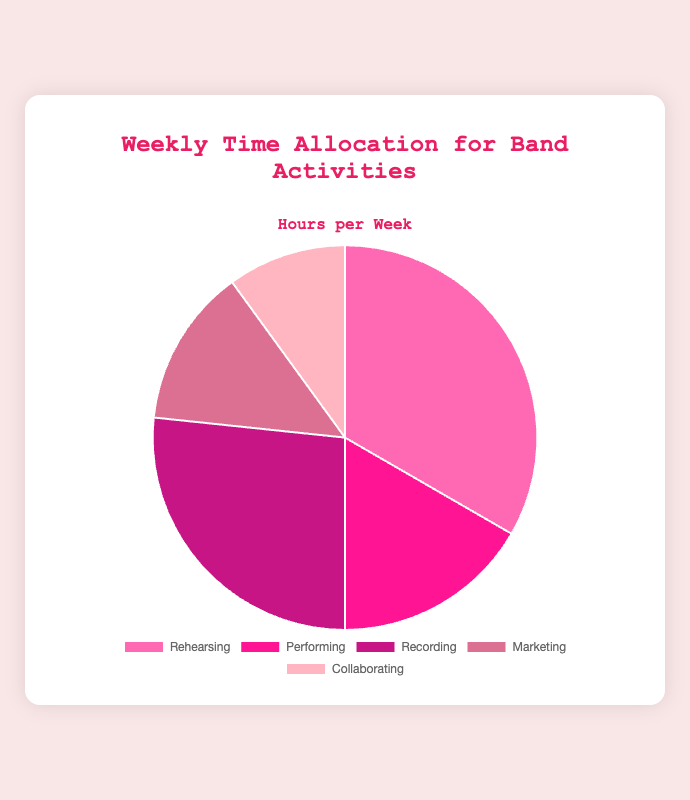What's the total amount of time allocated to Rehearsing and Recording? To find the total time, add the hours for Rehearsing (10) and Recording (8) together: 10 + 8 = 18 hours
Answer: 18 hours Which activity takes up the least amount of time? Collaborating has the smallest value (3 hours) compared to the other activities: Rehearsing (10), Performing (5), Recording (8), and Marketing (4)
Answer: Collaborating How much more time is spent Rehearsing than Marketing? To find the difference in time, subtract the hours for Marketing (4) from Rehearsing (10): 10 - 4 = 6 hours
Answer: 6 hours What's the combined time spent on Performing and Collaborating? Add the hours for Performing (5) and Collaborating (3) together: 5 + 3 = 8 hours
Answer: 8 hours Which activity has approximately one-fifth of the total time allocated? The total time is 30 hours. One-fifth of 30 is 6. Comparing this to individual activities, Performing (5) is closest to 6 hours
Answer: Performing What is the largest segment in the pie chart, and what color represents it? Rehearsing has the largest value (10 hours). The color representing Rehearsing is pink.
Answer: Rehearsing, pink How much more time is spent on Recording than Collaborating? Subtract the hours for Collaborating (3) from Recording (8): 8 - 3 = 5 hours
Answer: 5 hours Which activity takes a quarter of the total weekly time? The total time is 30 hours. A quarter of 30 is 7.5. Recording (8 hours) is closest to 7.5 hours.
Answer: Recording Is the time spent on Marketing more or less than the total time spent on Performing and Collaborating together? The total time for Performing and Collaborating is 5 + 3 = 8 hours. Marketing (4 hours) is less than 8 hours.
Answer: Less How much time is allocated to activities other than Rehearsing? Subtract the Rehearsing time (10) from the total time (30): 30 - 10 = 20 hours
Answer: 20 hours 